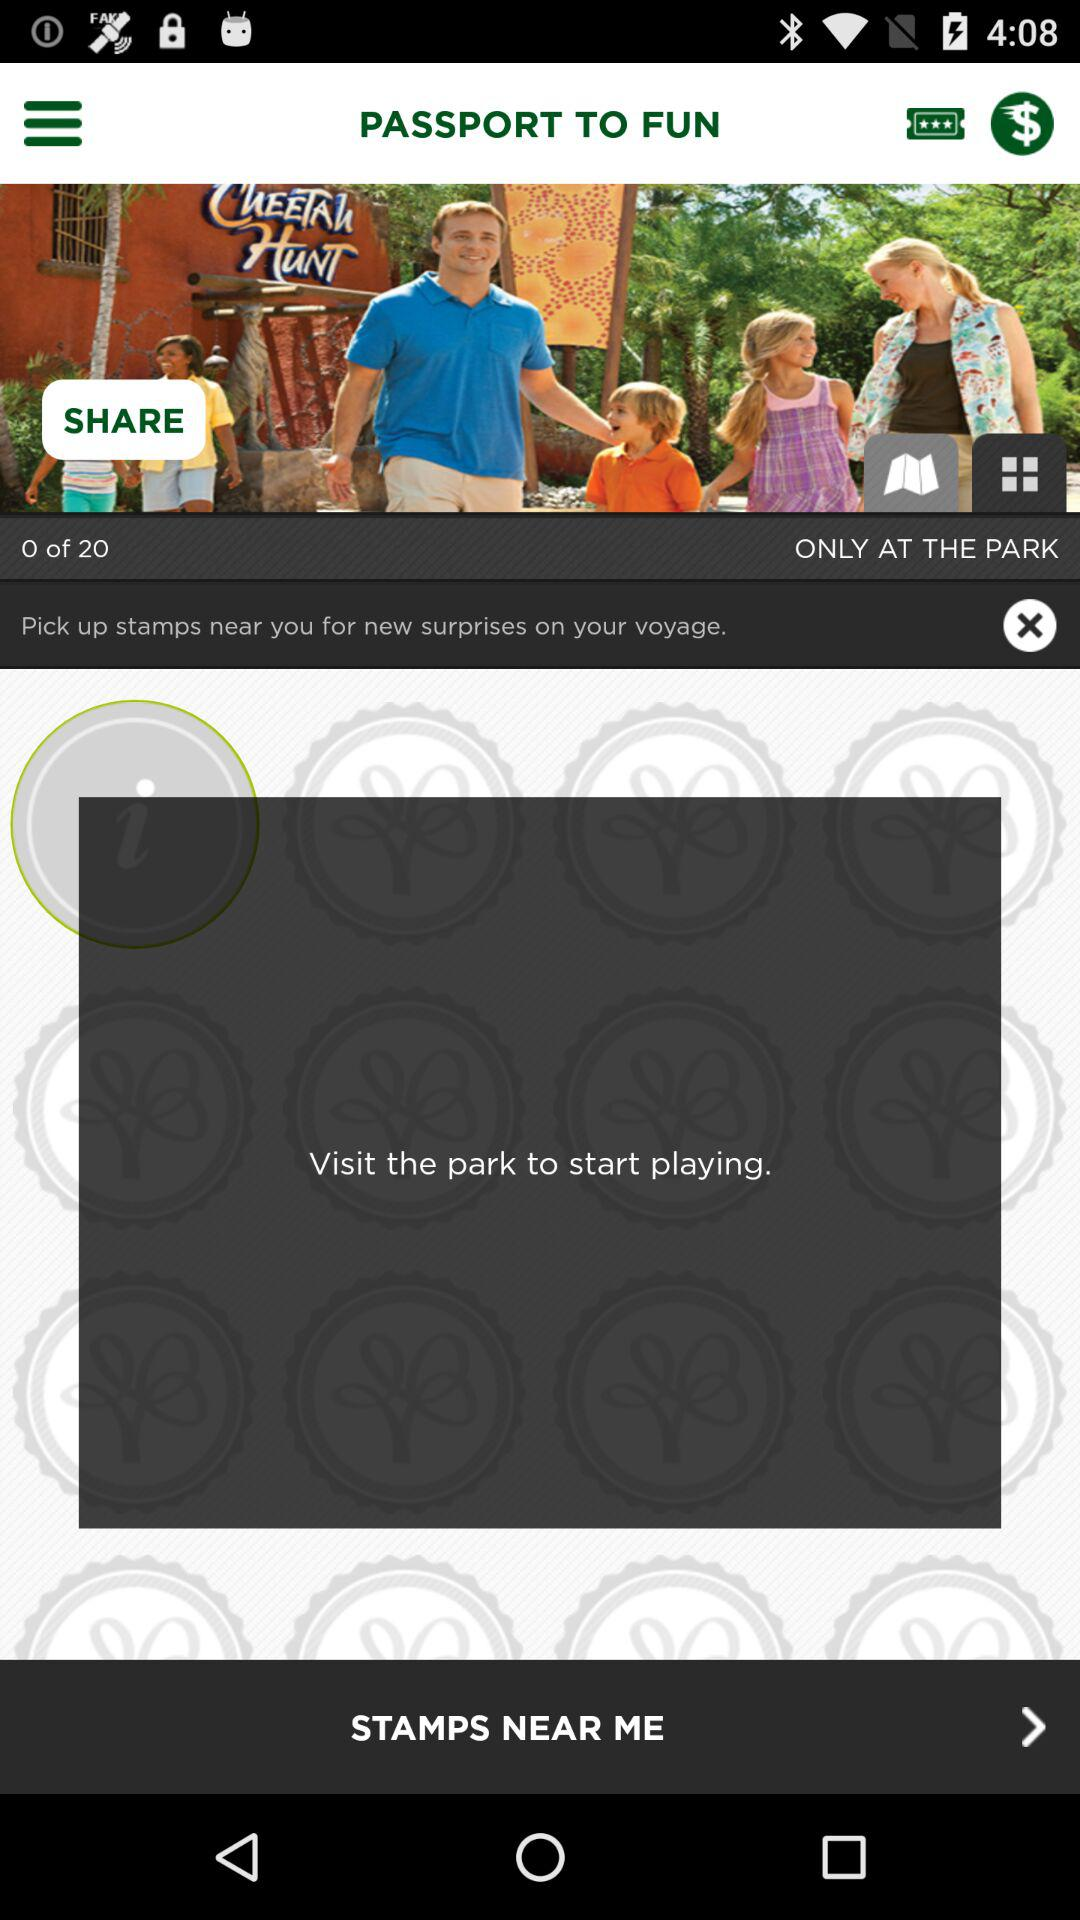What is the name of the application?
When the provided information is insufficient, respond with <no answer>. <no answer> 